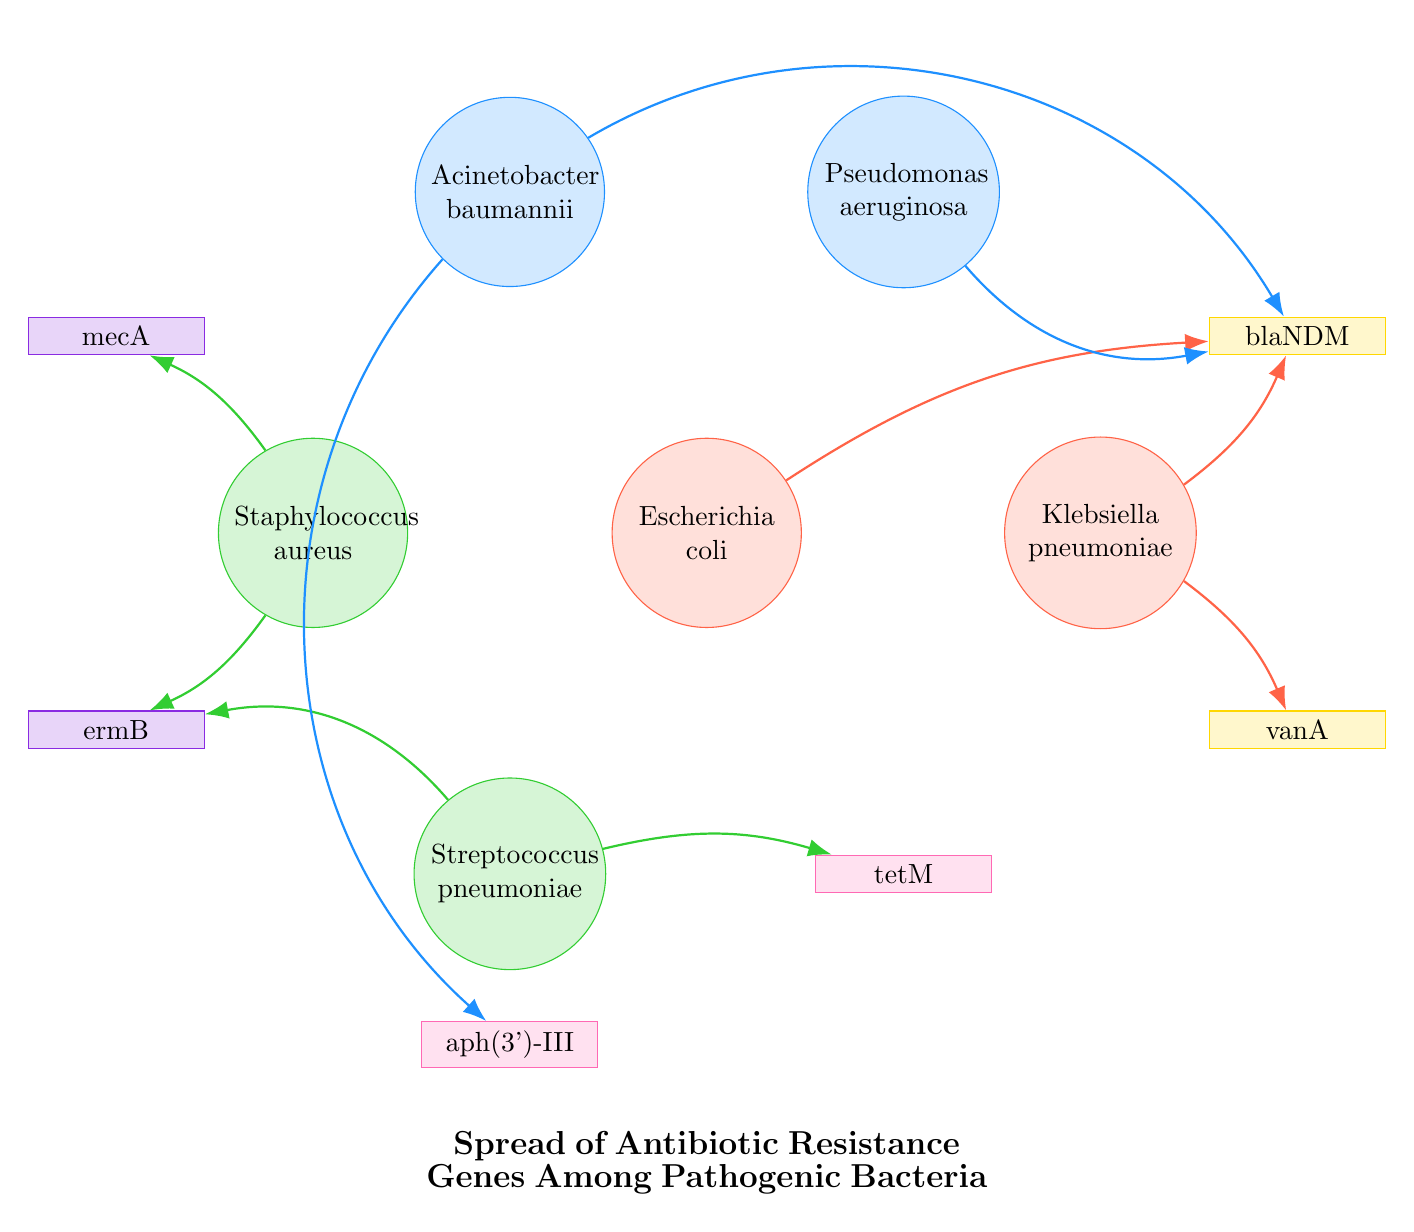What is the total number of nodes in the diagram? The diagram contains six bacterial nodes and six resistance gene nodes. Adding them together, we get 6 + 6 = 12 nodes.
Answer: 12 Which bacterial species is associated with the gene blaNDM? The connections in the diagram show that Escherichia coli, Klebsiella pneumoniae, Pseudomonas aeruginosa, and Acinetobacter baumannii all have edges leading to the gene blaNDM.
Answer: Escherichia coli, Klebsiella pneumoniae, Pseudomonas aeruginosa, Acinetobacter baumannii How many resistance genes are linked to Staphylococcus aureus? By examining the diagram, we can identify Staphylococcus aureus is connected to two resistance genes: mecA and ermB.
Answer: 2 Which gene is associated with the highest number of bacterial connections? Observing the links in the diagram, blaNDM has connections from four different bacteria: Escherichia coli, Klebsiella pneumoniae, Pseudomonas aeruginosa, and Acinetobacter baumannii, making it the gene with the highest connections.
Answer: blaNDM Which two bacteria are connected by the gene tetM? Staphylococcus pneumoniae has a direct link to the gene tetM based on the diagram. Therefore, the relationship is present only between Streptococcus pneumoniae and tetM.
Answer: Streptococcus pneumoniae What is the relationship between Klebsiella pneumoniae and vanA? The diagram indicates a direct link between Klebsiella pneumoniae and vanA, highlighting their relationship as connected.
Answer: Connected Which two bacterial species share a connection to ermB? The bacteria Staphylococcus aureus and Streptococcus pneumoniae both have connections to the gene ermB, making them share this relationship.
Answer: Staphylococcus aureus, Streptococcus pneumoniae How many resistance genes does Acinetobacter baumannii have connections to? By looking at the diagram, Acinetobacter baumannii has links to two resistance genes, which are blaNDM and aph(3')-III.
Answer: 2 Which gene is linked to both Klebsiella pneumoniae and Enterococcus faecium? The gene vanA has connections leading from both Klebsiella pneumoniae and Enterococcus faecium, indicating a relationship with both.
Answer: vanA 